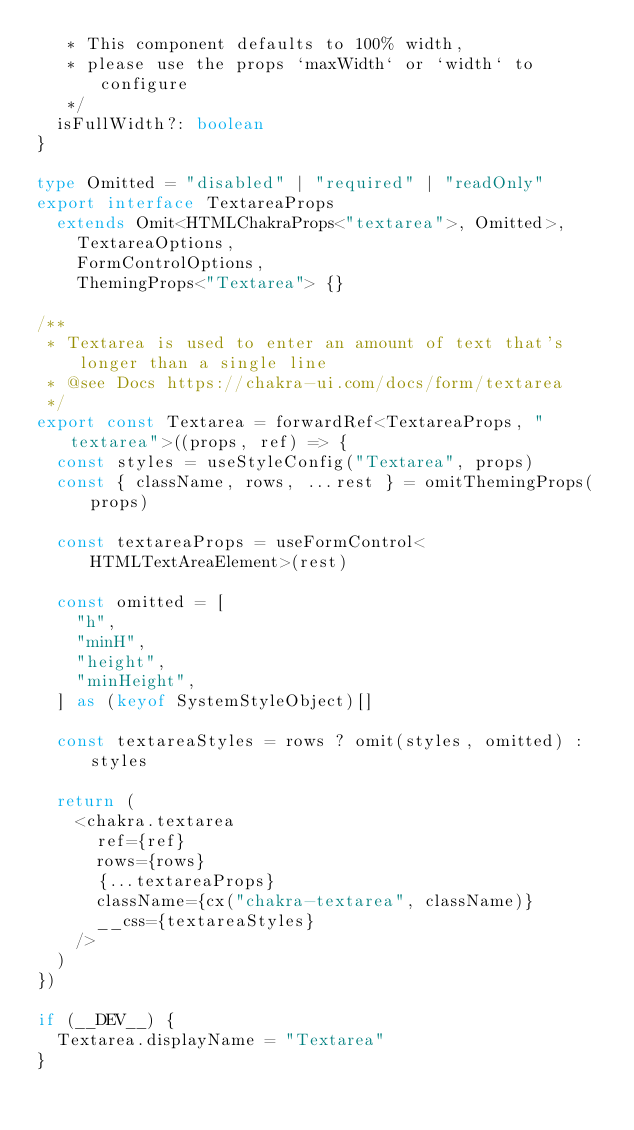Convert code to text. <code><loc_0><loc_0><loc_500><loc_500><_TypeScript_>   * This component defaults to 100% width,
   * please use the props `maxWidth` or `width` to configure
   */
  isFullWidth?: boolean
}

type Omitted = "disabled" | "required" | "readOnly"
export interface TextareaProps
  extends Omit<HTMLChakraProps<"textarea">, Omitted>,
    TextareaOptions,
    FormControlOptions,
    ThemingProps<"Textarea"> {}

/**
 * Textarea is used to enter an amount of text that's longer than a single line
 * @see Docs https://chakra-ui.com/docs/form/textarea
 */
export const Textarea = forwardRef<TextareaProps, "textarea">((props, ref) => {
  const styles = useStyleConfig("Textarea", props)
  const { className, rows, ...rest } = omitThemingProps(props)

  const textareaProps = useFormControl<HTMLTextAreaElement>(rest)

  const omitted = [
    "h",
    "minH",
    "height",
    "minHeight",
  ] as (keyof SystemStyleObject)[]

  const textareaStyles = rows ? omit(styles, omitted) : styles

  return (
    <chakra.textarea
      ref={ref}
      rows={rows}
      {...textareaProps}
      className={cx("chakra-textarea", className)}
      __css={textareaStyles}
    />
  )
})

if (__DEV__) {
  Textarea.displayName = "Textarea"
}
</code> 